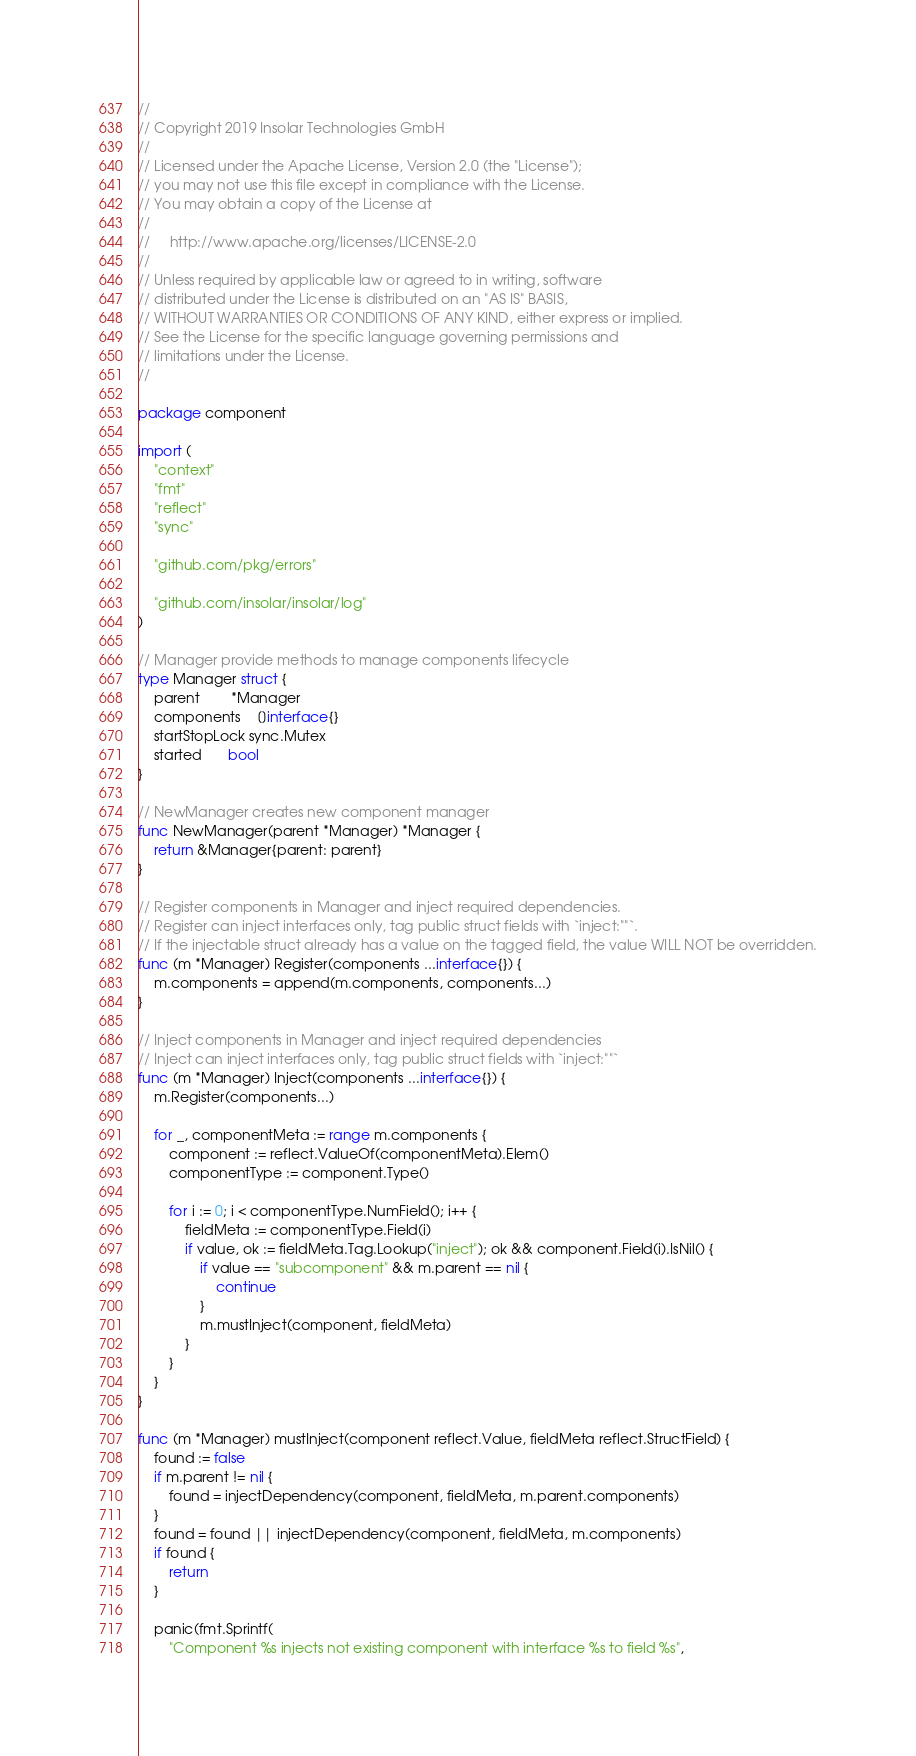<code> <loc_0><loc_0><loc_500><loc_500><_Go_>//
// Copyright 2019 Insolar Technologies GmbH
//
// Licensed under the Apache License, Version 2.0 (the "License");
// you may not use this file except in compliance with the License.
// You may obtain a copy of the License at
//
//     http://www.apache.org/licenses/LICENSE-2.0
//
// Unless required by applicable law or agreed to in writing, software
// distributed under the License is distributed on an "AS IS" BASIS,
// WITHOUT WARRANTIES OR CONDITIONS OF ANY KIND, either express or implied.
// See the License for the specific language governing permissions and
// limitations under the License.
//

package component

import (
	"context"
	"fmt"
	"reflect"
	"sync"

	"github.com/pkg/errors"

	"github.com/insolar/insolar/log"
)

// Manager provide methods to manage components lifecycle
type Manager struct {
	parent        *Manager
	components    []interface{}
	startStopLock sync.Mutex
	started       bool
}

// NewManager creates new component manager
func NewManager(parent *Manager) *Manager {
	return &Manager{parent: parent}
}

// Register components in Manager and inject required dependencies.
// Register can inject interfaces only, tag public struct fields with `inject:""`.
// If the injectable struct already has a value on the tagged field, the value WILL NOT be overridden.
func (m *Manager) Register(components ...interface{}) {
	m.components = append(m.components, components...)
}

// Inject components in Manager and inject required dependencies
// Inject can inject interfaces only, tag public struct fields with `inject:""`
func (m *Manager) Inject(components ...interface{}) {
	m.Register(components...)

	for _, componentMeta := range m.components {
		component := reflect.ValueOf(componentMeta).Elem()
		componentType := component.Type()

		for i := 0; i < componentType.NumField(); i++ {
			fieldMeta := componentType.Field(i)
			if value, ok := fieldMeta.Tag.Lookup("inject"); ok && component.Field(i).IsNil() {
				if value == "subcomponent" && m.parent == nil {
					continue
				}
				m.mustInject(component, fieldMeta)
			}
		}
	}
}

func (m *Manager) mustInject(component reflect.Value, fieldMeta reflect.StructField) {
	found := false
	if m.parent != nil {
		found = injectDependency(component, fieldMeta, m.parent.components)
	}
	found = found || injectDependency(component, fieldMeta, m.components)
	if found {
		return
	}

	panic(fmt.Sprintf(
		"Component %s injects not existing component with interface %s to field %s",</code> 